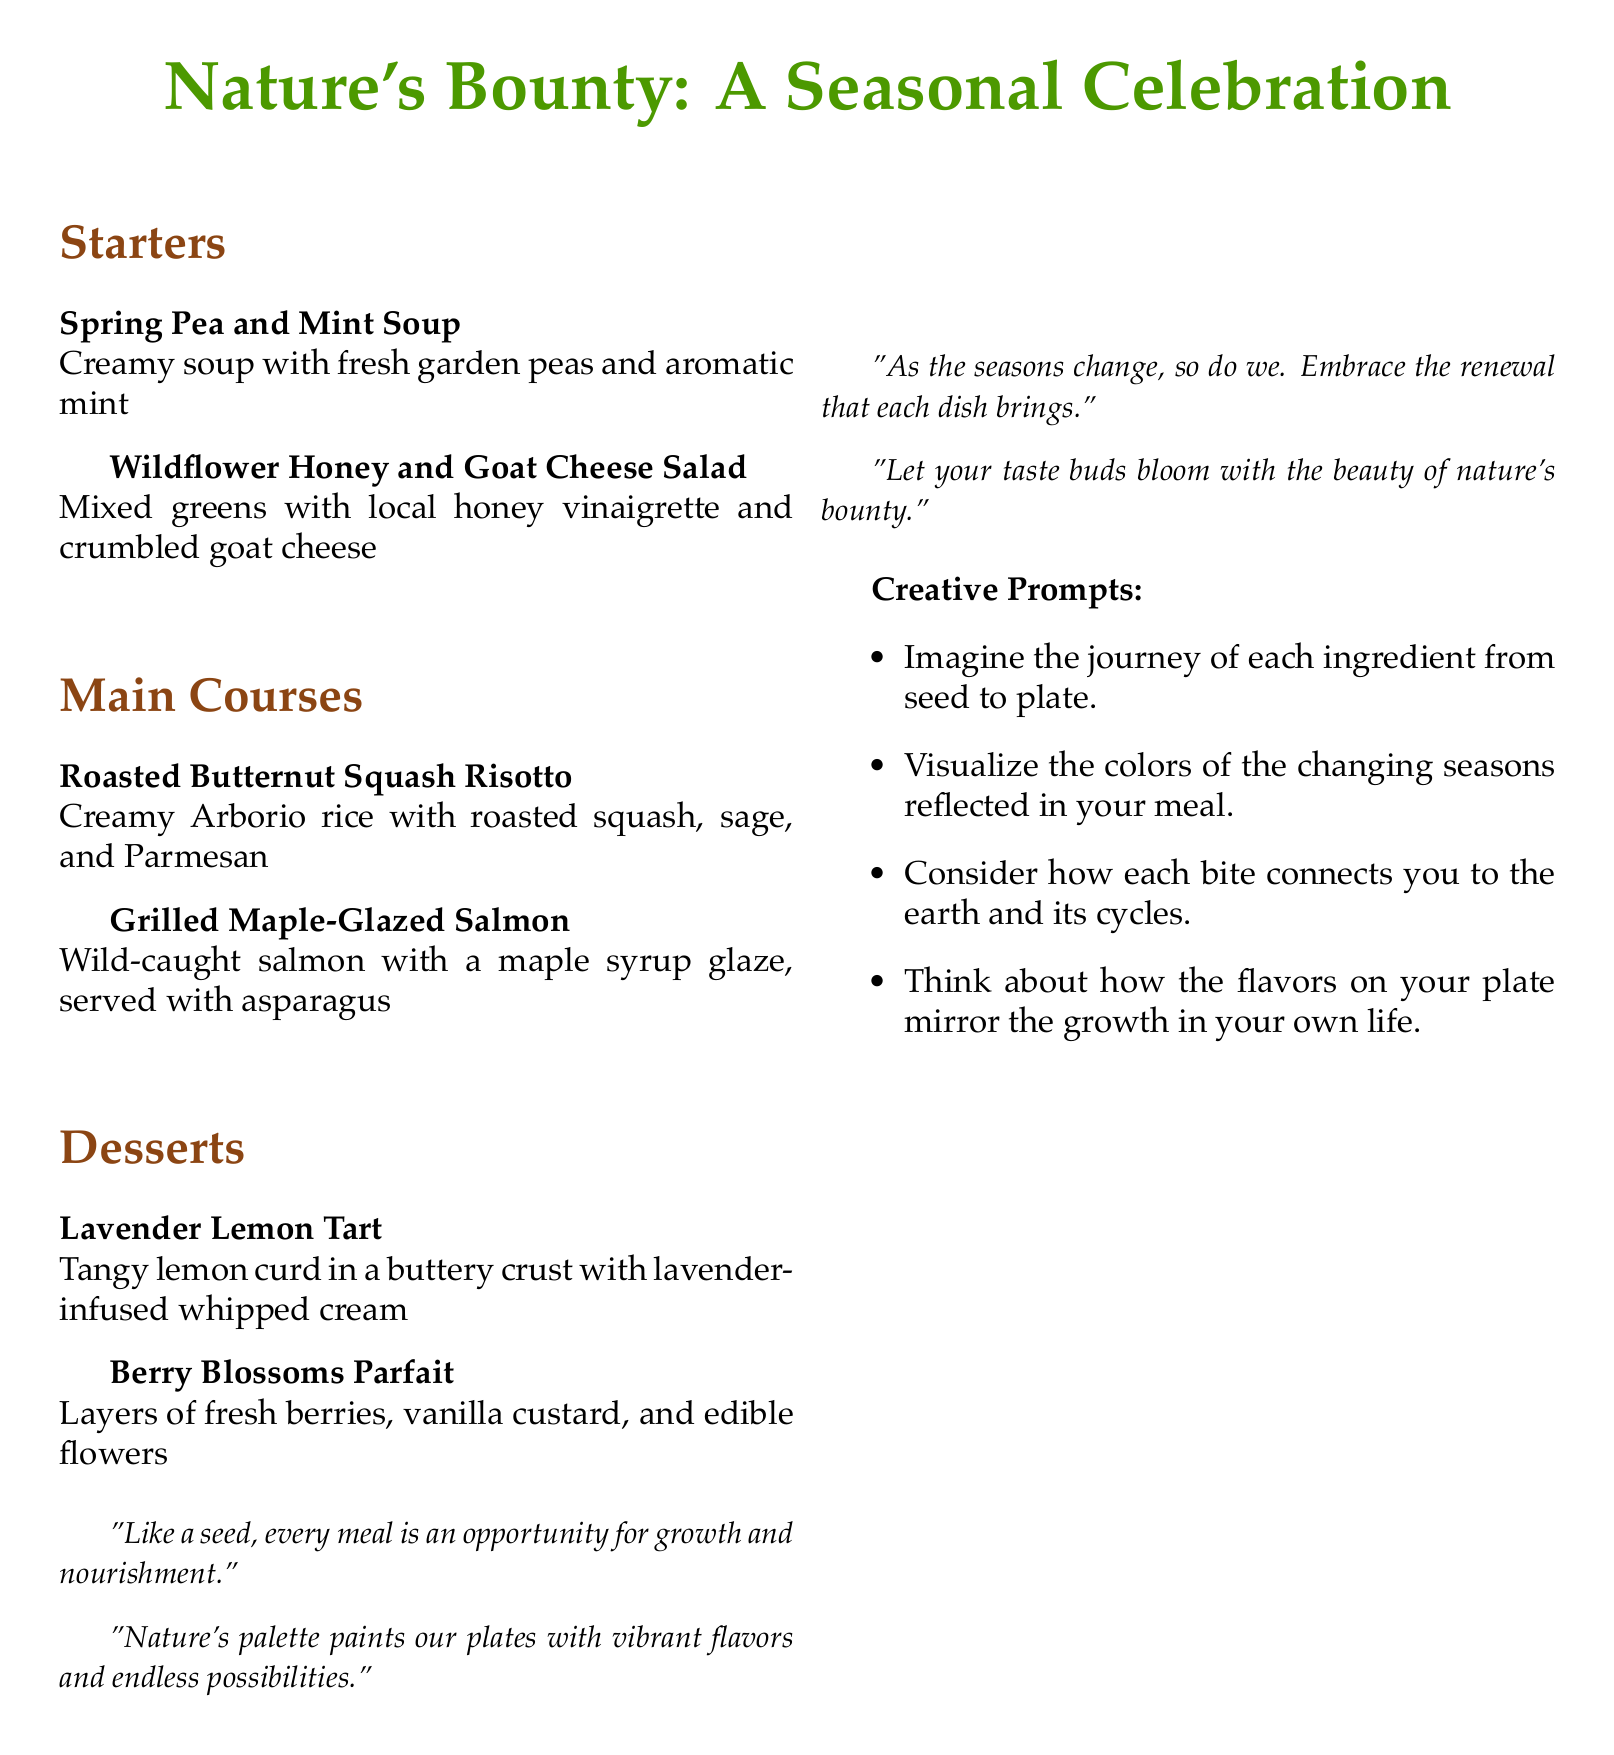What is the title of the menu? The title of the menu can be found at the top of the document and is indicated in large font.
Answer: Nature's Bounty: A Seasonal Celebration How many sections are in the menu? The menu is divided into three sections: Starters, Main Courses, and Desserts.
Answer: 3 What is the first item listed under Starters? The first item under Starters is found in the beginning of that section.
Answer: Spring Pea and Mint Soup What is the main ingredient in the Roasted Butternut Squash Risotto? The main ingredient is stated in the description of this dish under Main Courses.
Answer: Butternut Squash Which dessert contains lavender? This dessert is listed in the Desserts section and specifically mentions lavender in its name.
Answer: Lavender Lemon Tart What is the color associated with the section titles? The section titles are formatted in a specific color that is mentioned in the document.
Answer: Earthbrown How many creative prompts are provided? The number of creative prompts can be counted in the list found on the document.
Answer: 4 Which quote relates to the idea of embracing renewal? This quote is found at the bottom of the menu under the section with motivational quotes.
Answer: As the seasons change, so do we. Embrace the renewal that each dish brings What type of dish is the Grilled Maple-Glazed Salmon? This dish is categorized under Main Courses, indicating its type in the menu structure.
Answer: Main Course 